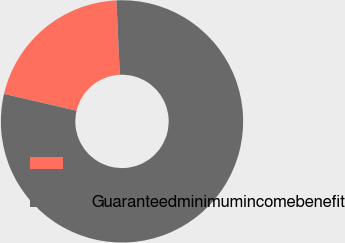Convert chart to OTSL. <chart><loc_0><loc_0><loc_500><loc_500><pie_chart><ecel><fcel>Guaranteedminimumincomebenefit<nl><fcel>20.62%<fcel>79.38%<nl></chart> 